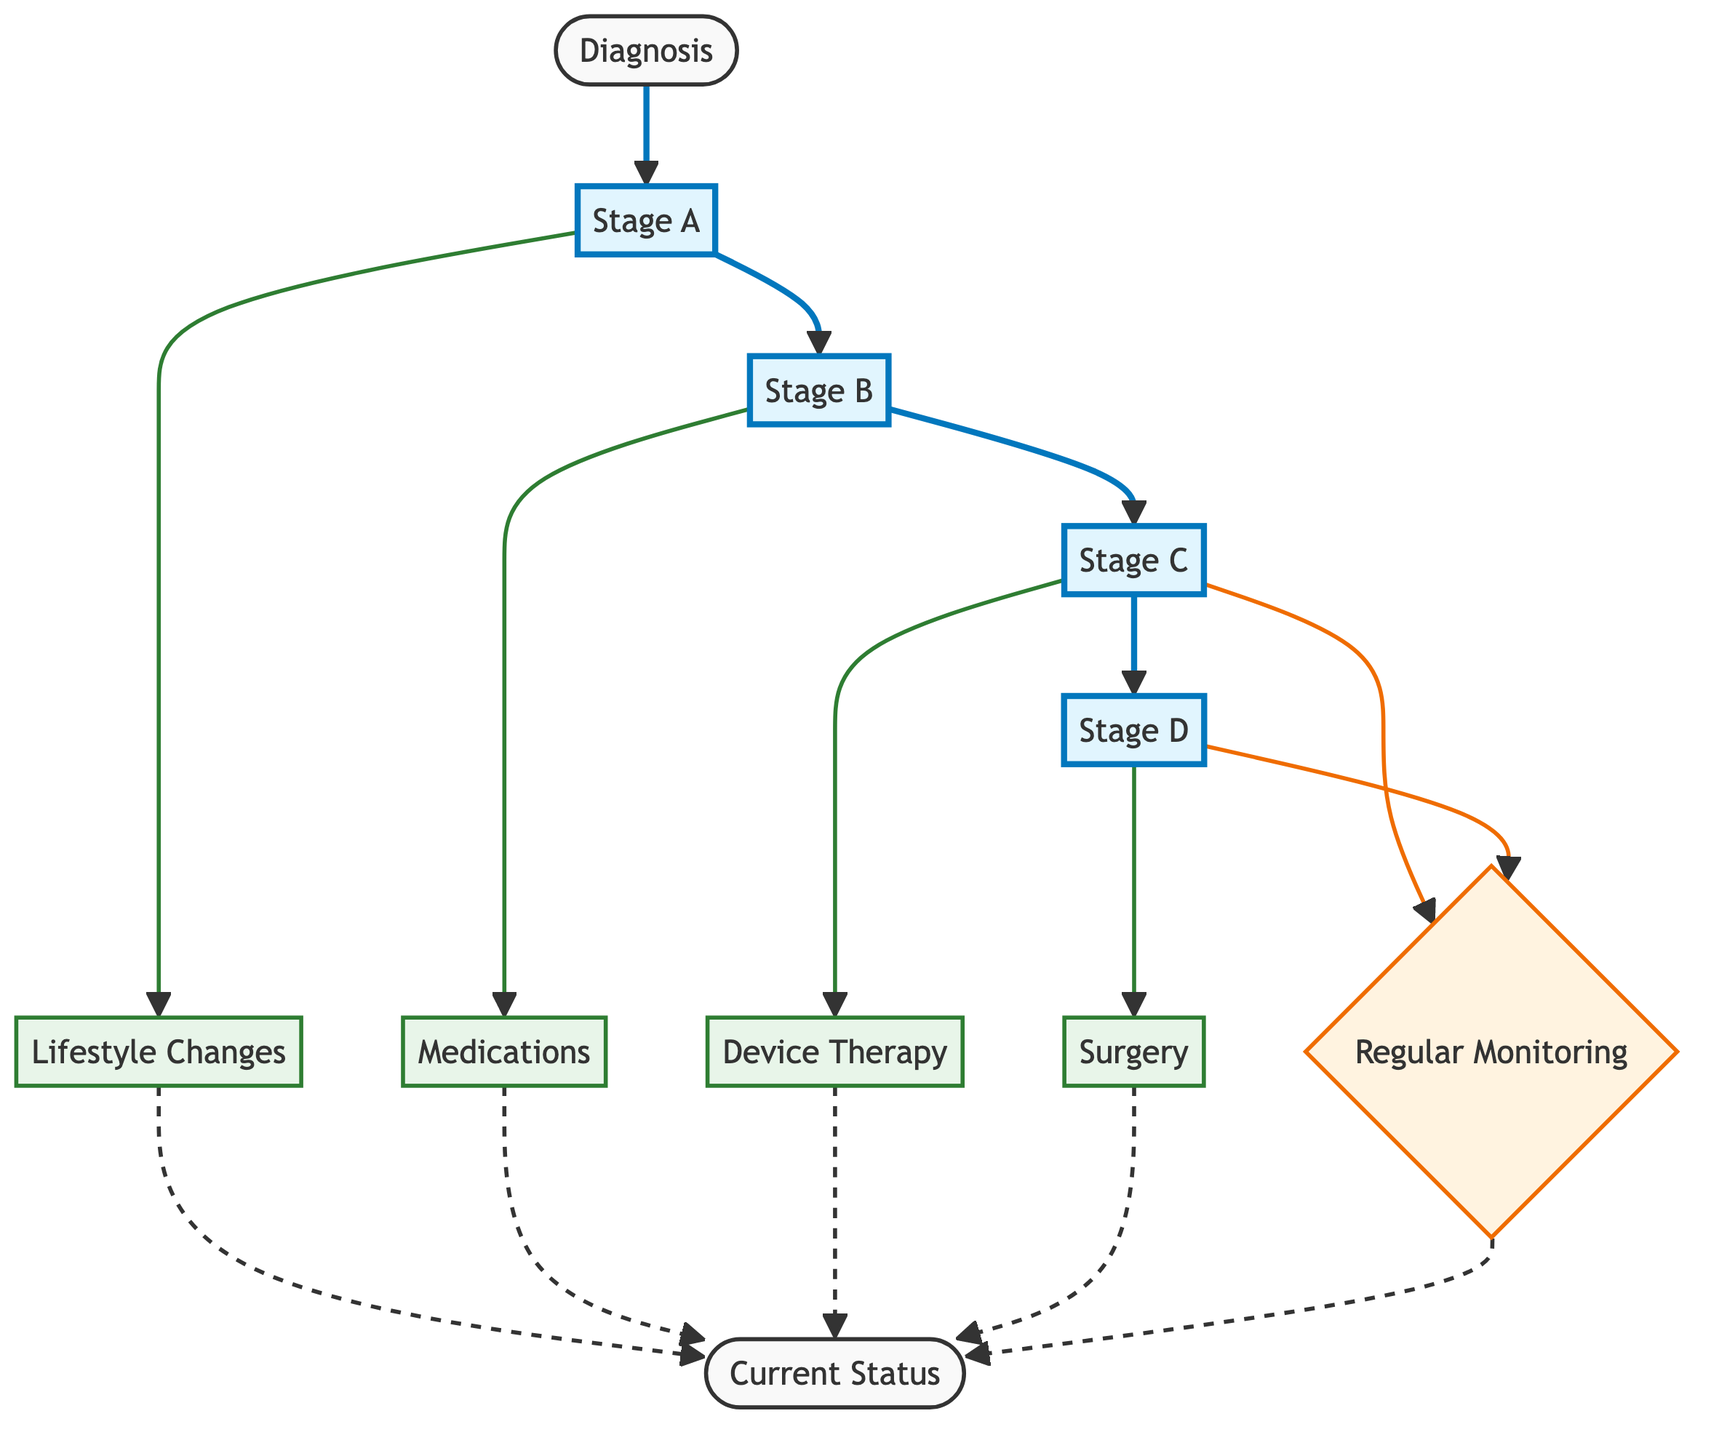What is the first stage of heart failure? The diagram indicates that the progression of heart failure starts with the "Stage A" node, which follows after the "Diagnosis" node.
Answer: Stage A How many treatment options are there in total? There are five treatment options represented in the diagram: "Lifestyle Changes," "Medications," "Device Therapy," "Surgery," and "Regular Monitoring."
Answer: 5 Which stage leads to device therapy? The diagram shows that "Stage C" leads to "Device Therapy," indicating that this is the point in heart failure progression where device therapy is introduced as a treatment option.
Answer: Stage C What is the last stage before the current status? The last stage before reaching the "Current Status" node is "Stage D," which is connected directly to the monitoring step and subsequently to the current status.
Answer: Stage D What management strategies are used in Stage B? According to the diagram, "Medications" are the management strategy that connects from "Stage B" to the current status, indicating its importance at this stage.
Answer: Medications Which stages involve regular monitoring? Both "Stage C" and "Stage D" lead to "Regular Monitoring," illustrating that monitoring is a critical strategy in managing heart failure at these stages.
Answer: Stage C, Stage D What flowchart color represents treatment options? The treatment options are represented in a green color scheme, specifically using the "treatment" class defined in the diagram.
Answer: Green How many stages are included in the progression of heart failure? The diagram outlines four distinct stages of heart failure: Stage A, Stage B, Stage C, and Stage D, establishing a clear progression from diagnosis to advanced stages.
Answer: 4 